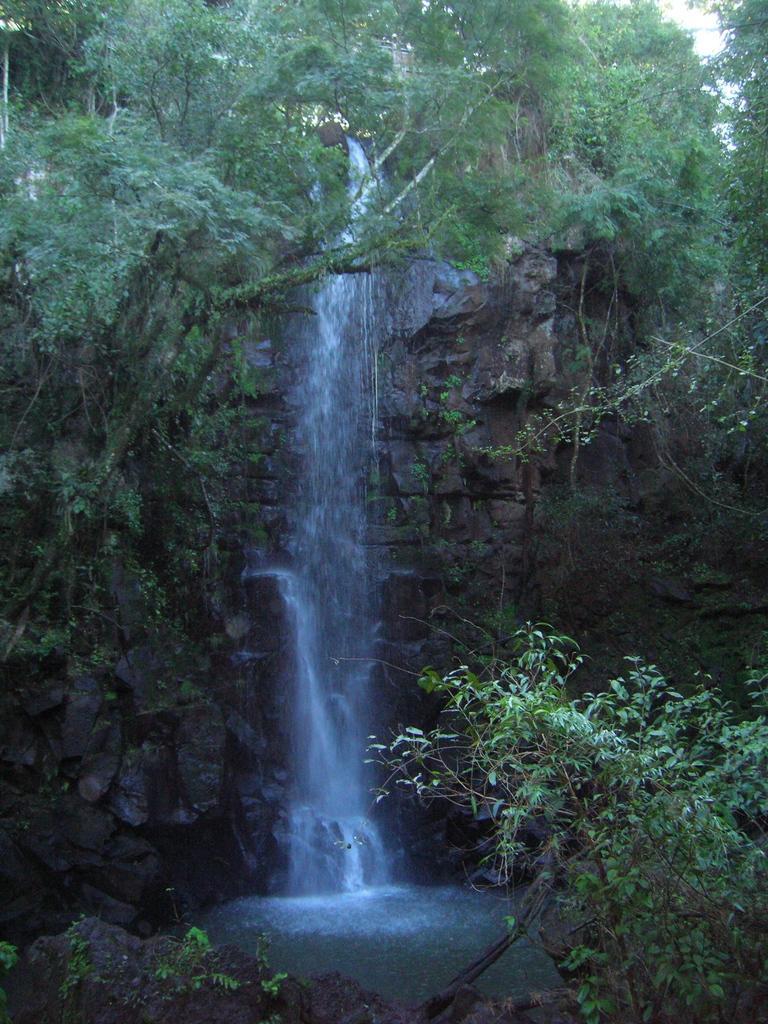Please provide a concise description of this image. In this image, we can see waterfall. We can also see some trees. At the bottom, we can see some water. 